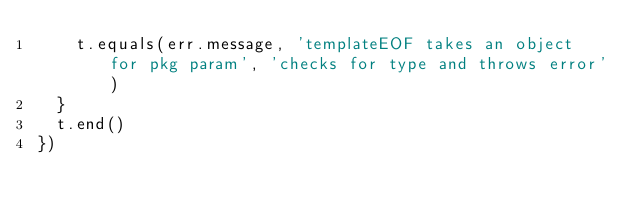<code> <loc_0><loc_0><loc_500><loc_500><_JavaScript_>    t.equals(err.message, 'templateEOF takes an object for pkg param', 'checks for type and throws error')
  }
  t.end()
})

</code> 